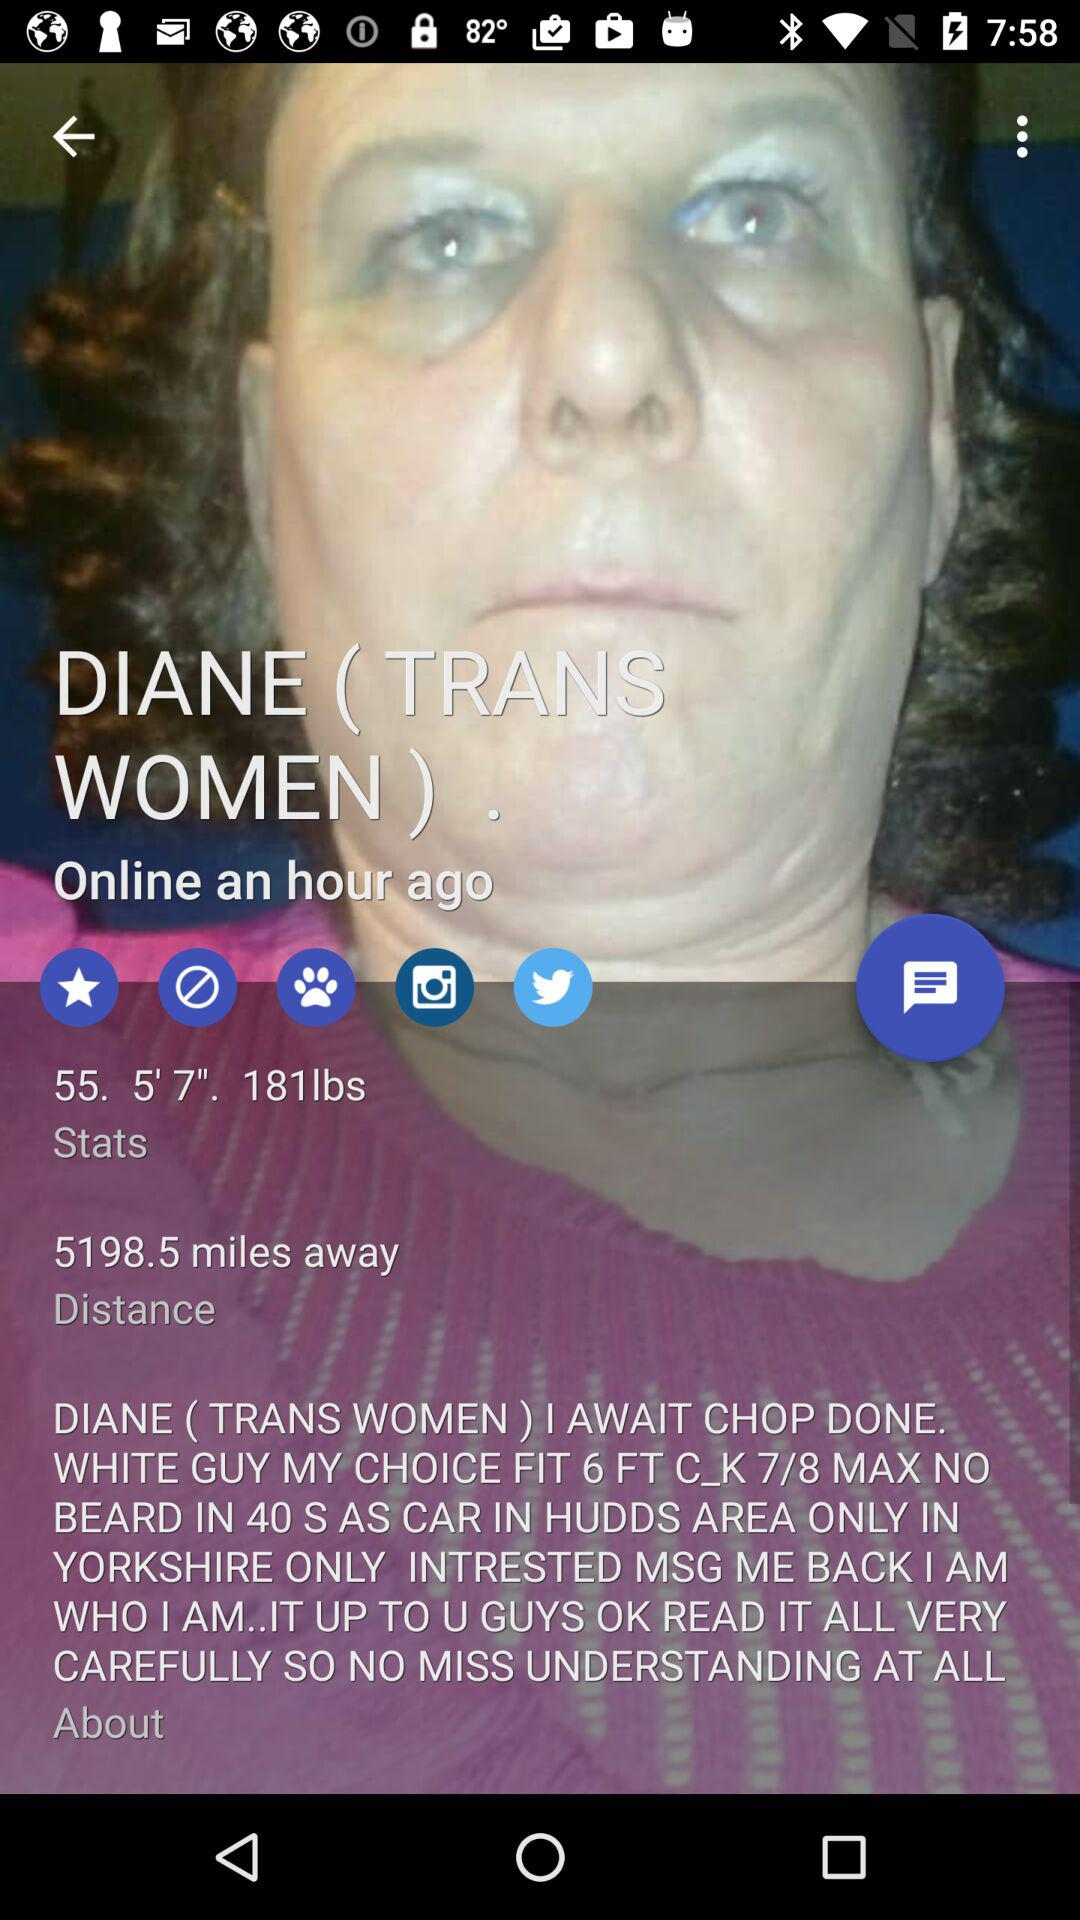What is the given weight? The given weight is 181 pounds. 